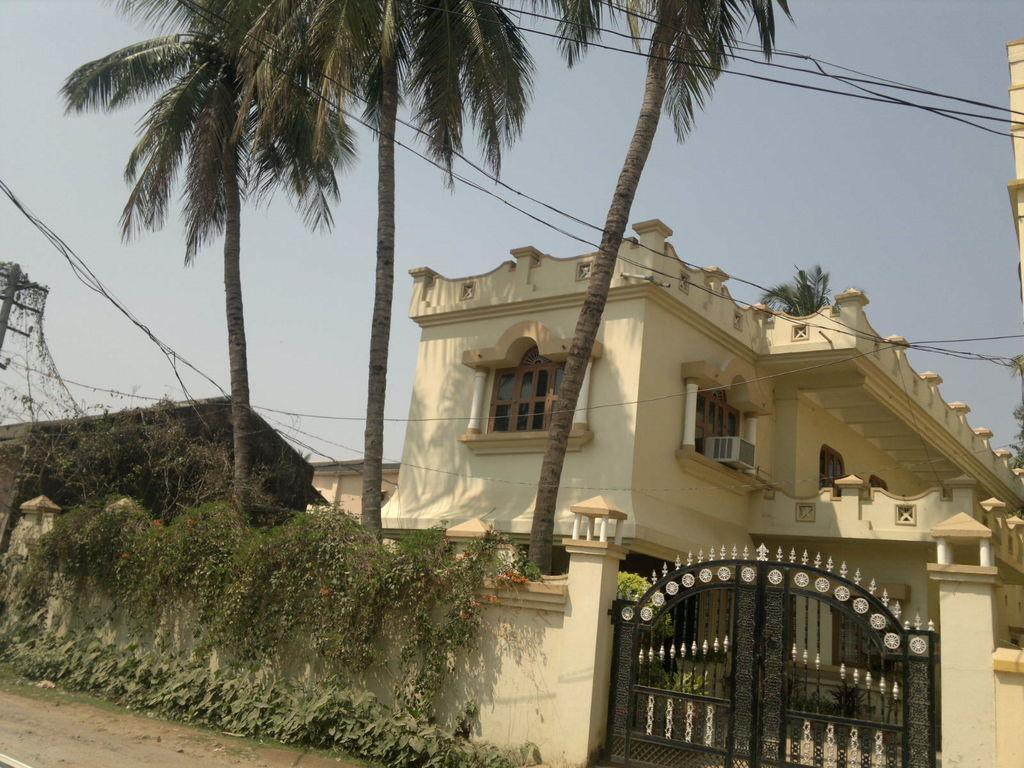What type of structure is in the image? There is a building in the image. What feature can be seen on the building? The building has windows. What type of vegetation is around the building? There are trees and plants around the building. What else is visible in the image? There are wires visible in the image. Are there any firemen present in the image? There is no indication of firemen in the image. What type of destruction can be seen happening to the building in the image? There is no destruction visible in the image; the building appears intact. 